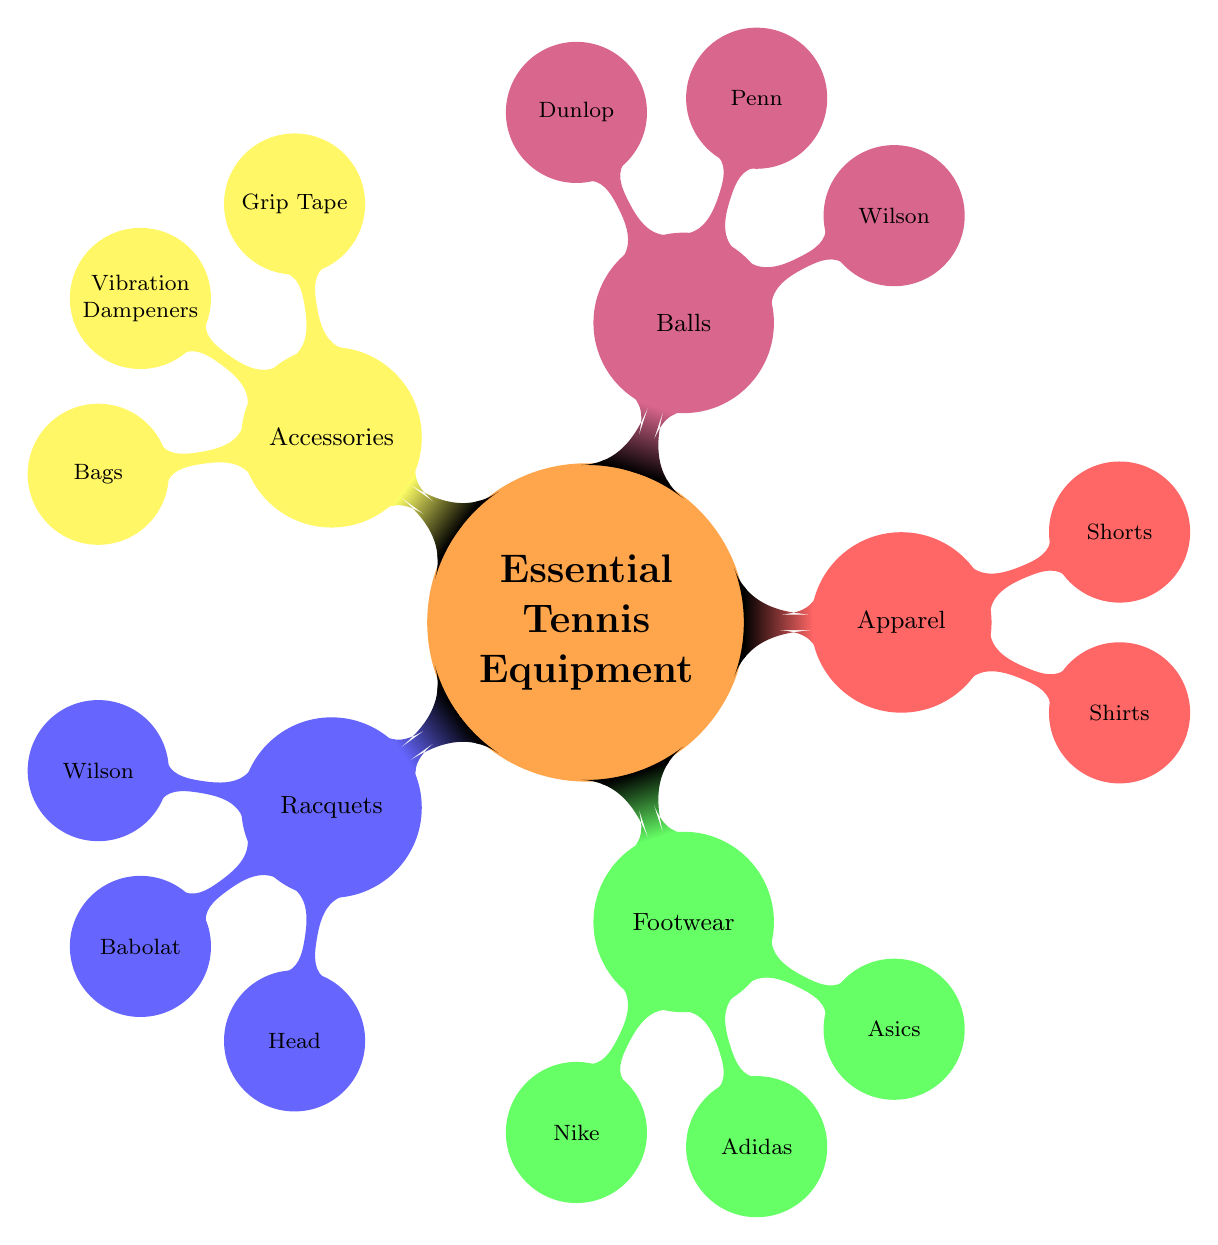What are the types of footwear listed? The diagram shows three brands under the Footwear category: Nike, Adidas, and Asics. This information is directly visible in the corresponding node.
Answer: Nike, Adidas, Asics Which brand of racquet has the model "Pure Drive"? Looking at the Racquets section, the brand Babolat is listed with the model "Pure Drive." Thus, Babolat is the answer to this question.
Answer: Babolat How many types of Balls are depicted in the diagram? The Balls category includes three brands: Wilson, Penn, and Dunlop. Therefore, by counting these nodes, we find there are three types.
Answer: 3 What type of apparel includes "Court Flex Ace"? The "Court Flex Ace" is categorized under Shorts in the Apparel section. This can be found by tracing back from the specific model to its higher-level category.
Answer: Shorts Which brand offers the "Shelf Packs" bag? The Bags section shows two options: Babolat with "Pure Aero 12 Pack" and Wilson with "RF DNA 12 Pack." Analyzing these options indicates that neither specifically states "Shelf Packs," but the inquiry can be considered a misunderstanding. Still, the answer would be Wilson or Babolat based on the context.
Answer: Babolat or Wilson (no "Shelf Packs" mentioned) How many brands are associated with the Accessories category? In the Accessories section, we see three types: Grip Tape, Vibration Dampeners, and Bags. Each of these has specific brands listed beneath them. To count the unique brands, we see that Tourna, Wilson, Sorbothane, Babolat, and others are present. Therefore, the total number of unique brands under Accessories is five.
Answer: 5 